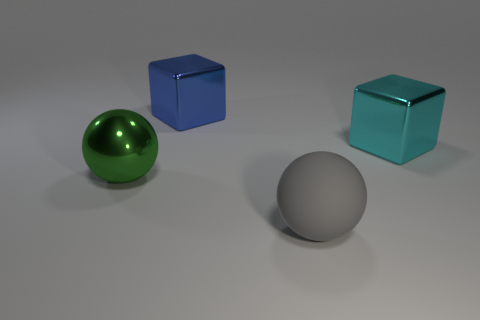Is there a large shiny block behind the large metal block that is on the right side of the big ball on the right side of the big green sphere?
Make the answer very short. Yes. Does the metal object that is to the right of the gray thing have the same shape as the blue metal thing on the right side of the green shiny object?
Make the answer very short. Yes. There is a big ball that is made of the same material as the large blue thing; what color is it?
Offer a very short reply. Green. Are there fewer big green spheres to the right of the green metallic sphere than large cyan cylinders?
Your response must be concise. No. How big is the metallic cube that is behind the big shiny cube that is on the right side of the large ball right of the green ball?
Provide a short and direct response. Large. Is the material of the big ball behind the gray rubber object the same as the big blue cube?
Offer a terse response. Yes. How many objects are blue blocks or big gray matte objects?
Your answer should be very brief. 2. How many other objects are the same color as the large metal sphere?
Your answer should be compact. 0. How many cubes are either tiny blue metallic objects or big gray matte objects?
Keep it short and to the point. 0. There is a big block that is in front of the large cube that is behind the cyan metal cube; what color is it?
Keep it short and to the point. Cyan. 